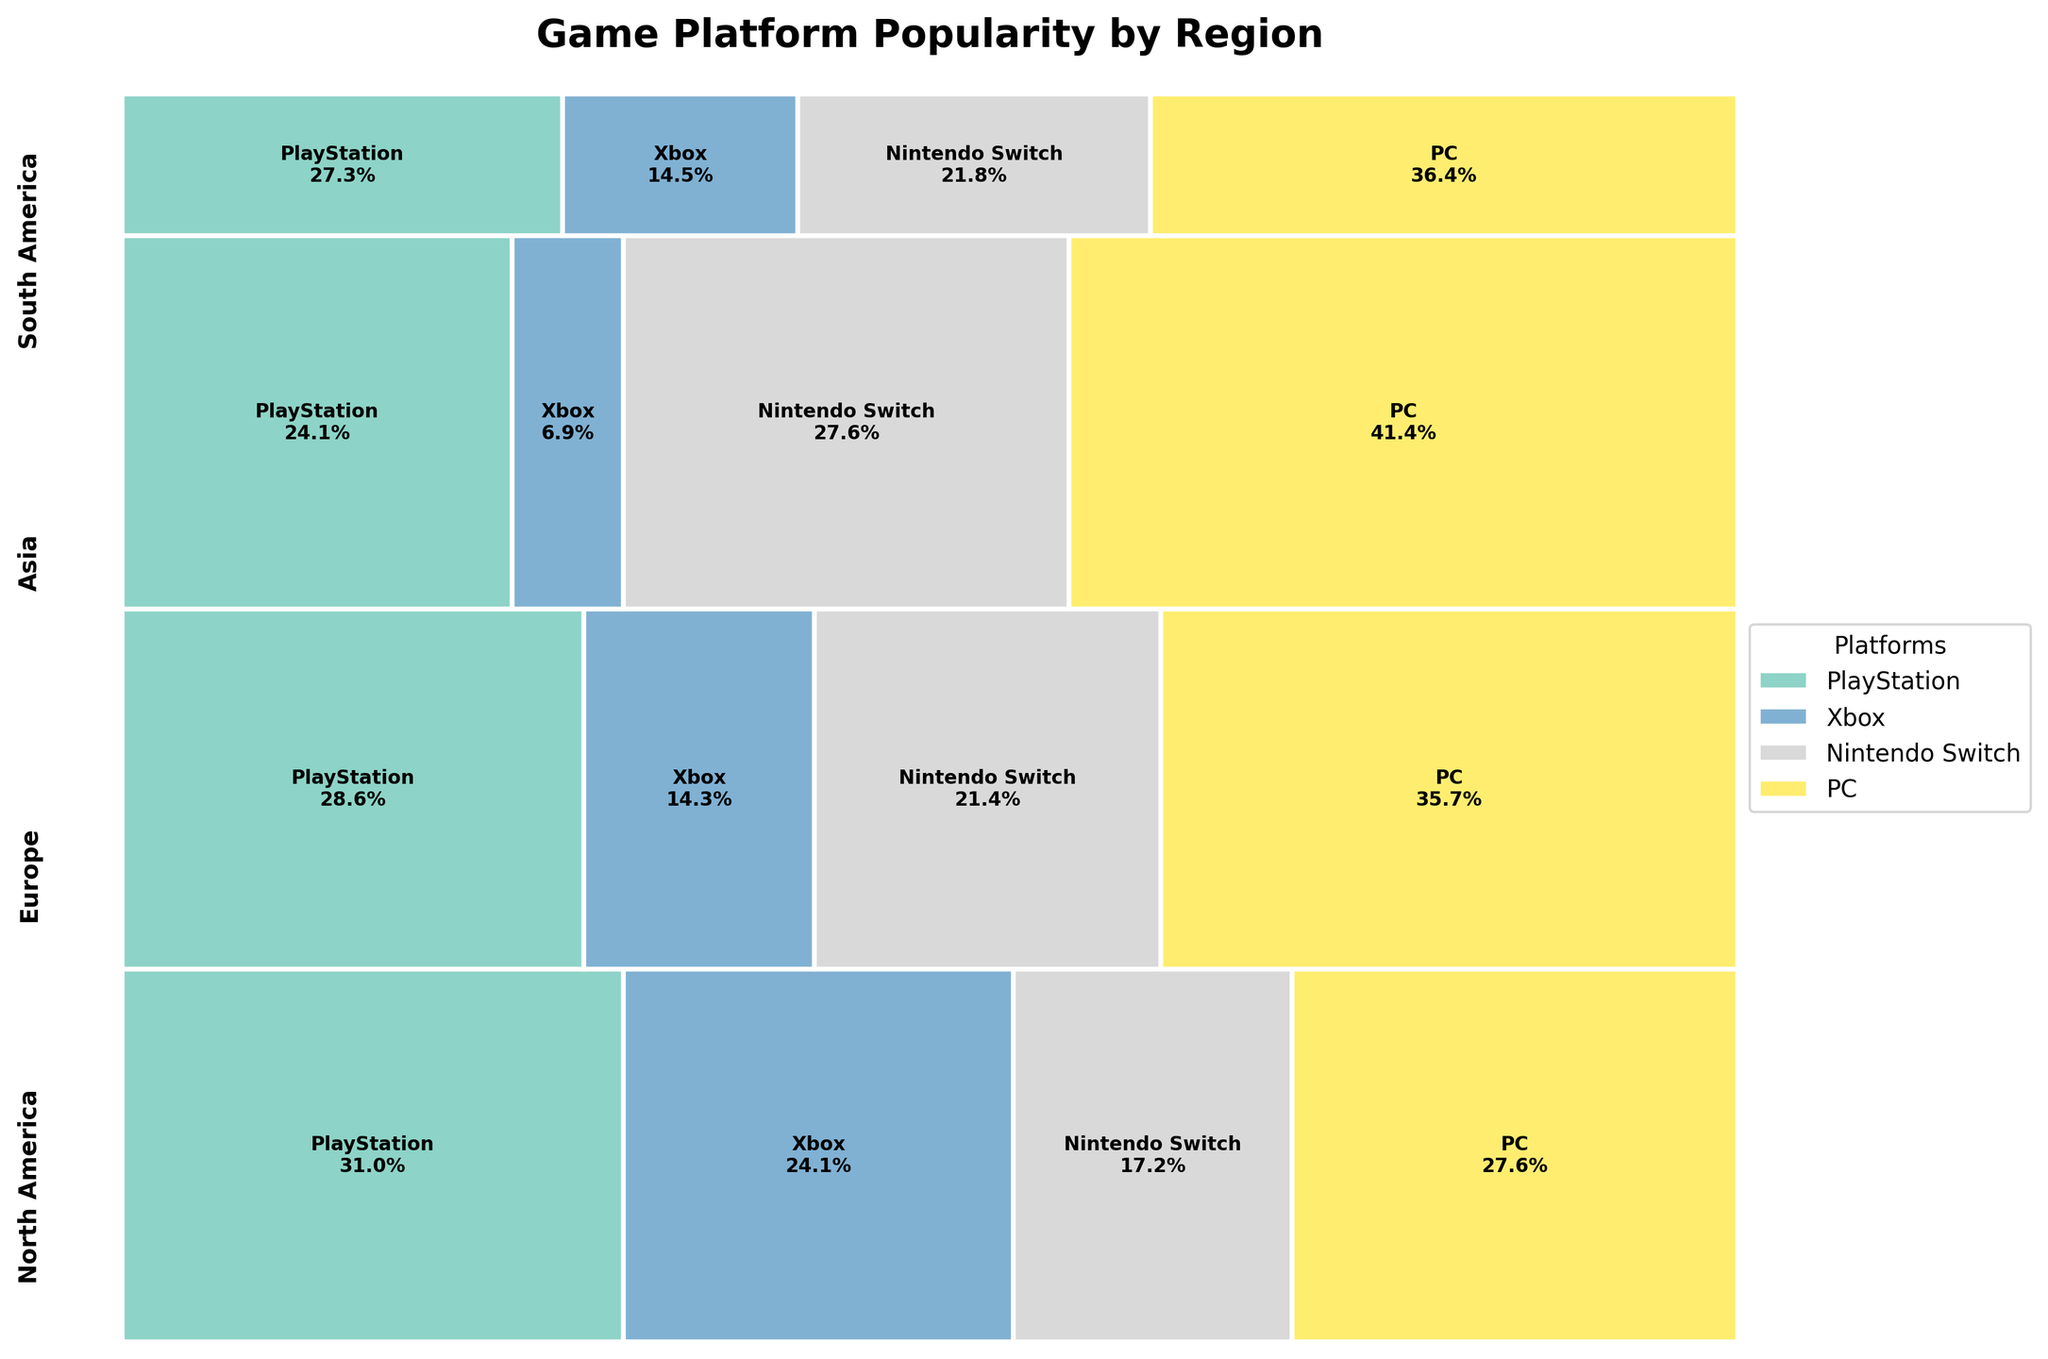What's the title of the figure? The title of a plot is usually displayed at the top of the figure. This title helps give a summary of what the plot is displaying.
Answer: Game Platform Popularity by Region Which game platform segment is largest in North America? To determine this, look at the widths of each colored segment within the North America region on the mosaic plot. The width of a segment represents the number of users for that platform.
Answer: PlayStation How do the popularity percentages of PC users compare between Europe and Asia? Look at the relative sizes (widths) of the PC segments in the Europe and Asia regions on the mosaic plot. Compare them by visually assessing which one is larger.
Answer: Asia > Europe Which region has the smallest percentage for the Xbox platform? Examine the Xbox segments in all regions. The region with the smallest-width segment for Xbox represents the smallest percentage.
Answer: Asia What is the total percentage of users for Nintendo Switch in all regions combined relative to their respective regions? Calculate the width of the Nintendo Switch segments within each region and sum them up: 25000000 in North America, 30000000 in Europe, 40000000 in Asia, and 12000000 in South America. Calculate (25 + 30 + 40 + 12)%.
Answer: 107% In which region does PC have the highest percentage of users? Check the segments representing the PC platform across all regions and identify the region with the widest segment for the PC platform.
Answer: Asia How does the overall distribution of platforms in South America compare to North America? Compare the widths of each platform’s segments within both South America and North America regions visually. Observe which platforms are more or less popular relatively within each region.
Answer: South America shows more balanced user distribution compared to the dominance of PlayStation and PC in North America Which platform in Europe has the second highest user percentage? Look at the segments in Europe and determine the relative sizes. The second widest segment after the widest (PC) will be the platform with the second highest percentage.
Answer: PlayStation What's the overall popularity trend for the Xbox platform across all regions? Examine the Xbox segments across all regions and identify any visual patterns or trends in segment widths. Compare these widths to notice declines or inclines.
Answer: Declining from North America to Asia to South America What is the combined user percentage of PlayStation and Xbox in Europe? Identify and sum the widths of the PlayStation and Xbox segments in Europe from the mosaic plot. The sum is the combined user percentage.
Answer: 60% 